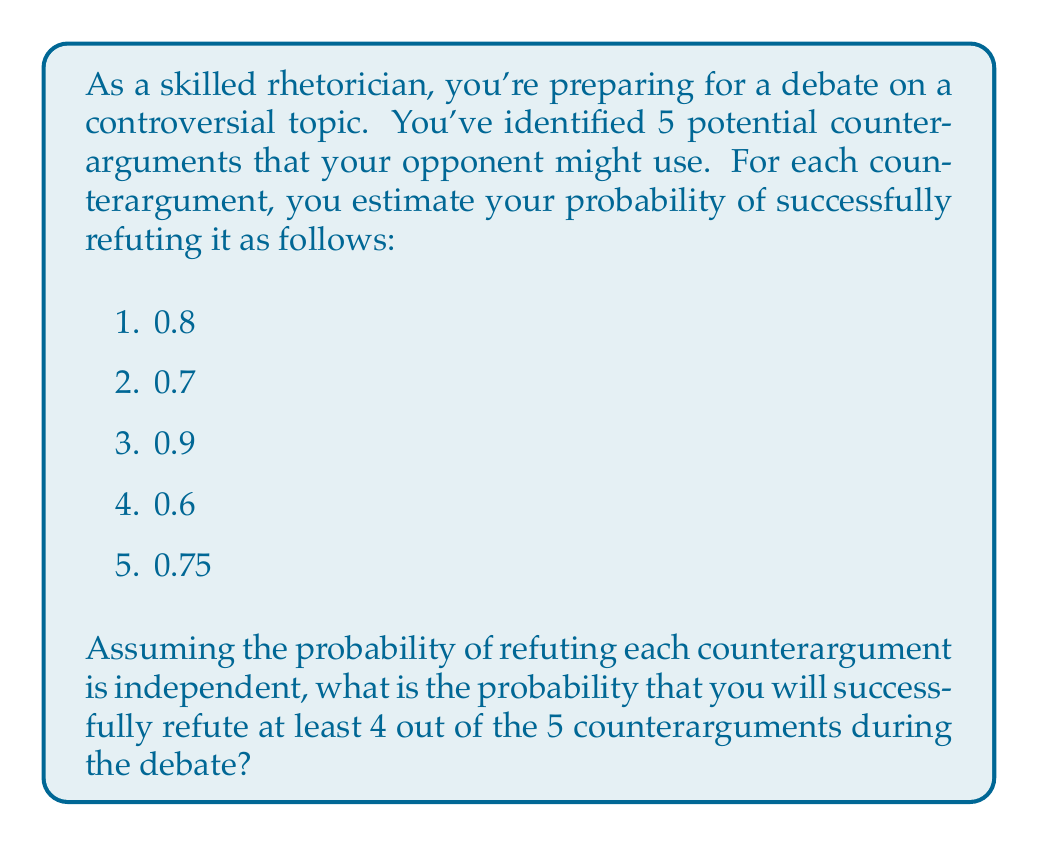Could you help me with this problem? To solve this problem, we'll use the concept of binomial probability. We need to calculate the probability of successfully refuting either 4 or 5 counterarguments out of 5.

Let's define success as refuting a counterargument and failure as not refuting it.

Step 1: Calculate the probability of success (p) and failure (q) for each counterargument.
p = (0.8 + 0.7 + 0.9 + 0.6 + 0.75) / 5 = 0.75
q = 1 - p = 0.25

Step 2: Use the binomial probability formula to calculate the probability of exactly 4 successes:
$$P(X = 4) = \binom{5}{4} p^4 q^1 = 5 \cdot (0.75)^4 \cdot (0.25)^1 = 0.3955$$

Step 3: Calculate the probability of exactly 5 successes:
$$P(X = 5) = \binom{5}{5} p^5 q^0 = 1 \cdot (0.75)^5 \cdot (0.25)^0 = 0.2373$$

Step 4: Sum the probabilities of 4 and 5 successes to get the probability of at least 4 successes:
$$P(X \geq 4) = P(X = 4) + P(X = 5) = 0.3955 + 0.2373 = 0.6328$$

Therefore, the probability of successfully refuting at least 4 out of the 5 counterarguments is approximately 0.6328 or 63.28%.
Answer: 0.6328 or 63.28% 